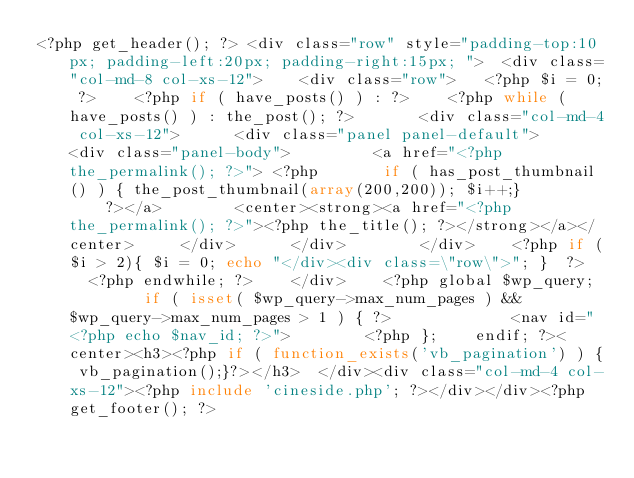Convert code to text. <code><loc_0><loc_0><loc_500><loc_500><_PHP_><?php get_header(); ?> <div class="row" style="padding-top:10px; padding-left:20px; padding-right:15px; ">	<div class="col-md-8 col-xs-12">		<div class="row">		<?php $i = 0; ?>		<?php if ( have_posts() ) : ?>		<?php while ( have_posts() ) : the_post(); ?>	  		<div class="col-md-4 col-xs-12">			<div class="panel panel-default">				<div class="panel-body">				 <a href="<?php the_permalink(); ?>"> <?php 		 	if ( has_post_thumbnail() ) { the_post_thumbnail(array(200,200)); $i++;} 						?></a>				<center><strong><a href="<?php the_permalink(); ?>"><?php the_title(); ?></strong></a></center>			</div>			</div>	  		</div>		<?php if ($i > 2){ $i = 0; echo "</div><div class=\"row\">"; }  ?>		<?php endwhile; ?>		</div>		<?php global $wp_query;	        if ( isset( $wp_query->max_num_pages ) && $wp_query->max_num_pages > 1 ) { ?>	            <nav id="<?php echo $nav_id; ?>">        <?php };    endif; ?><center><h3><?php if ( function_exists('vb_pagination') ) {	vb_pagination();}?></h3>	</div><div class="col-md-4 col-xs-12"><?php include 'cineside.php'; ?></div></div><?php get_footer(); ?>
</code> 